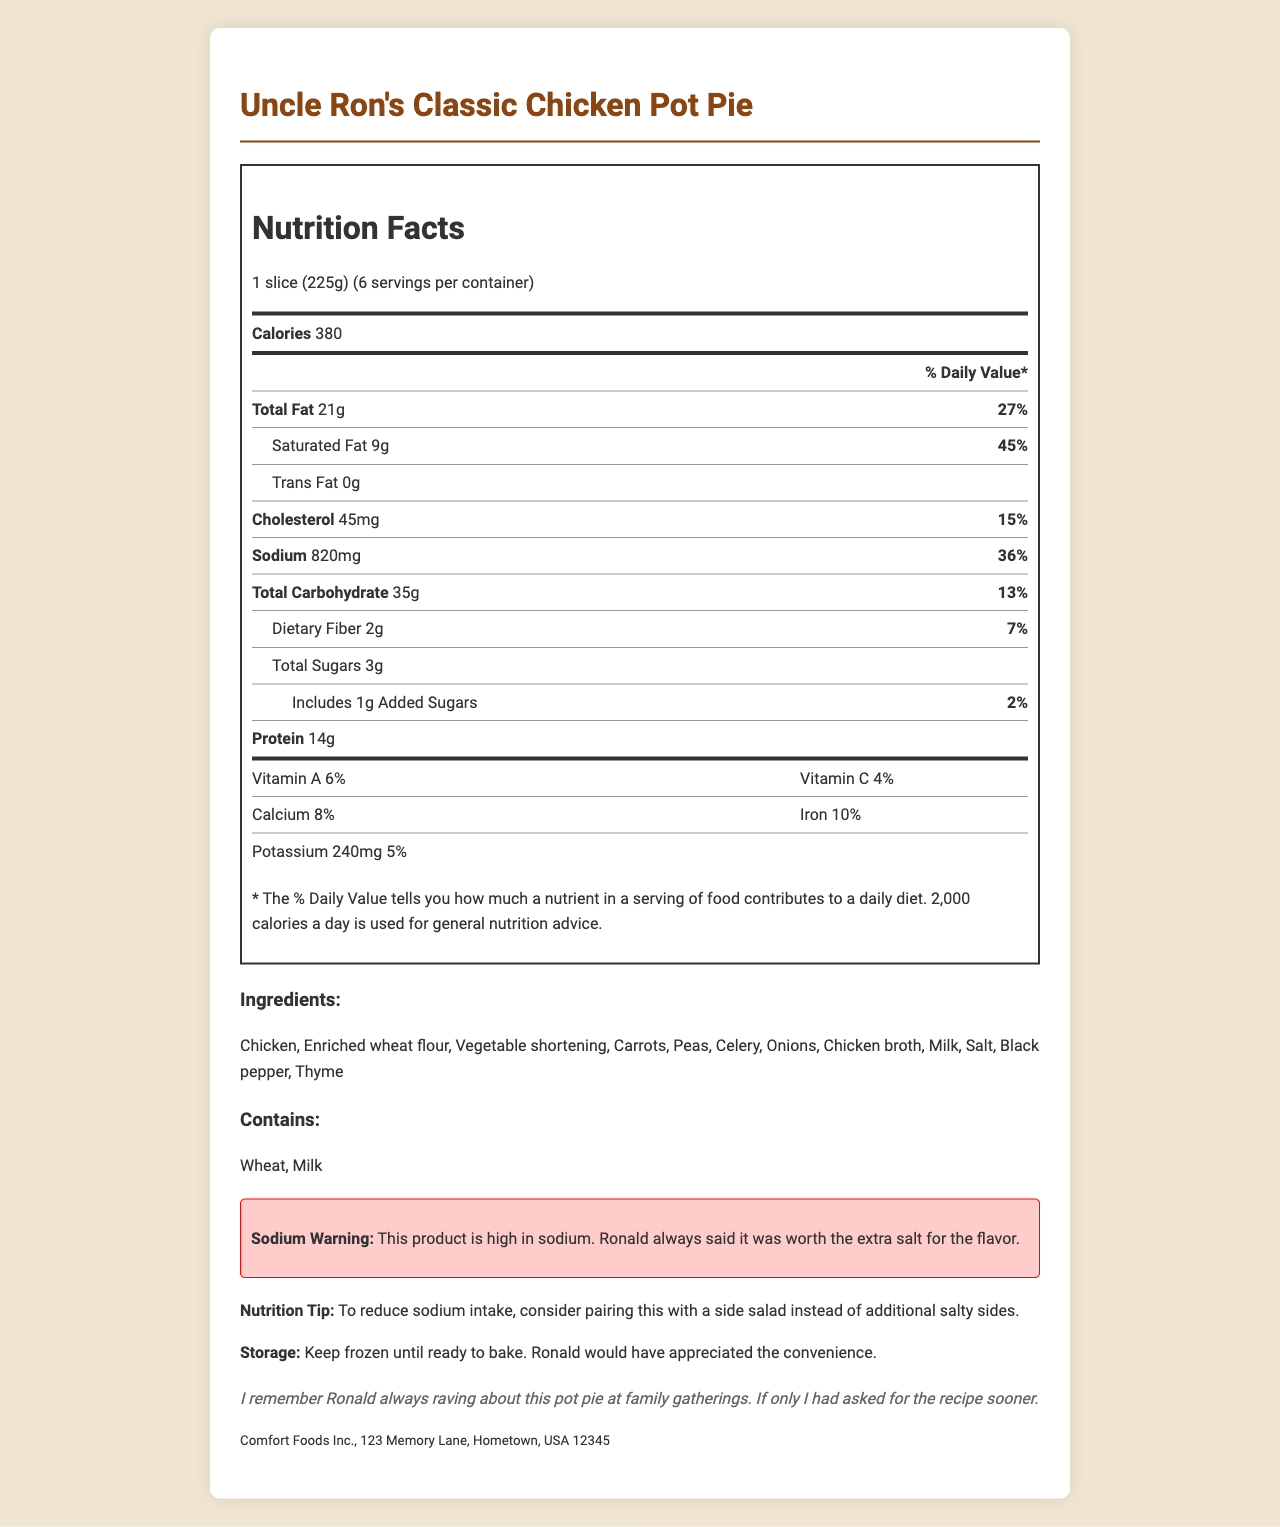who manufactures Uncle Ron's Classic Chicken Pot Pie? The document states the manufacturer as "Comfort Foods Inc., 123 Memory Lane, Hometown, USA 12345."
Answer: Comfort Foods Inc. What is the serving size of the pot pie? The document lists the serving size as "1 slice (225g)."
Answer: 1 slice (225g) How much sodium does one serving of Uncle Ron's Classic Chicken Pot Pie contain? The sodium content per serving is stated as "820mg."
Answer: 820mg What is the % Daily Value of saturated fat per serving? The document specifies the % Daily Value (DV) for saturated fat as "45%."
Answer: 45% List some of the main ingredients in Uncle Ron's Classic Chicken Pot Pie. The ingredients list includes "Chicken, Enriched wheat flour, Vegetable shortening, Carrots, Peas, Celery, Onions, Chicken broth, Milk, Salt, Black pepper, and Thyme."
Answer: Chicken, Enriched wheat flour, Vegetable shortening, Carrots, Peas How many calories are in one serving of the pot pie? The document states "Calories" at 380 per serving.
Answer: 380 calories Which of the following is an allergen in this product? A. Peanuts B. Wheat C. Soy The allergens listed are "Wheat" and "Milk."
Answer: B. Wheat What is the nutrition tip provided for reducing sodium intake? A. Drink more water B. Cook without salt C. Pair with a side salad The document provides the nutrition tip: "To reduce sodium intake, consider pairing this with a side salad instead of additional salty sides."
Answer: C. Pair with a side salad Is potassium content mentioned on the nutrition label? The document mentions potassium content with "Potassium 240mg."
Answer: Yes What are the storage instructions for Uncle Ron's Classic Chicken Pot Pie? The document states to "Keep frozen until ready to bake."
Answer: Keep frozen until ready to bake. What is Ronald's favorite recipe according to the manufacturer note? The manufacturer note says, "Ronald's favorite recipe, now available frozen for your convenience."
Answer: Uncle Ron's Classic Chicken Pot Pie Summarize the main idea of the entire document. The document is an extensive nutritional facts label and additional content regarding "Uncle Ron's Classic Chicken Pot Pie." It includes serving size, calorie count, nutritional content, allergens, ingredients, and storage instructions. It also contains a personal family memory of Ronald, a warning about the high sodium content, nutritional advice, and notes on the convenience and storage.
Answer: The document provides nutritional information, ingredients, allergens, a family memory, and storage instructions for "Uncle Ron's Classic Chicken Pot Pie," highlighting its high sodium content with tips to reduce sodium intake, and a manufacturer note about Ronald's fondness for the recipe. What is the total carbohydrate content per serving? The document states "Total Carbohydrate" as "35g."
Answer: 35g Who is Ronald in the family memory section? The document references Ronald in the family memory section but does not provide enough information to determine exactly who he was.
Answer: Cannot be determined 